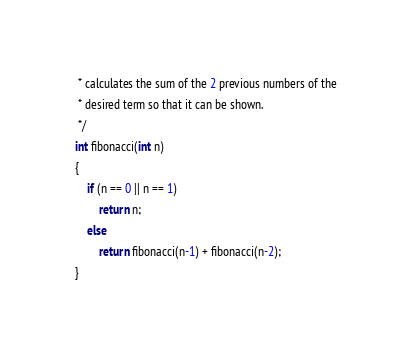<code> <loc_0><loc_0><loc_500><loc_500><_C_> * calculates the sum of the 2 previous numbers of the 
 * desired term so that it can be shown.
 */
int fibonacci(int n)
{
	if (n == 0 || n == 1)
		return n;
	else
		return fibonacci(n-1) + fibonacci(n-2);
}
</code> 